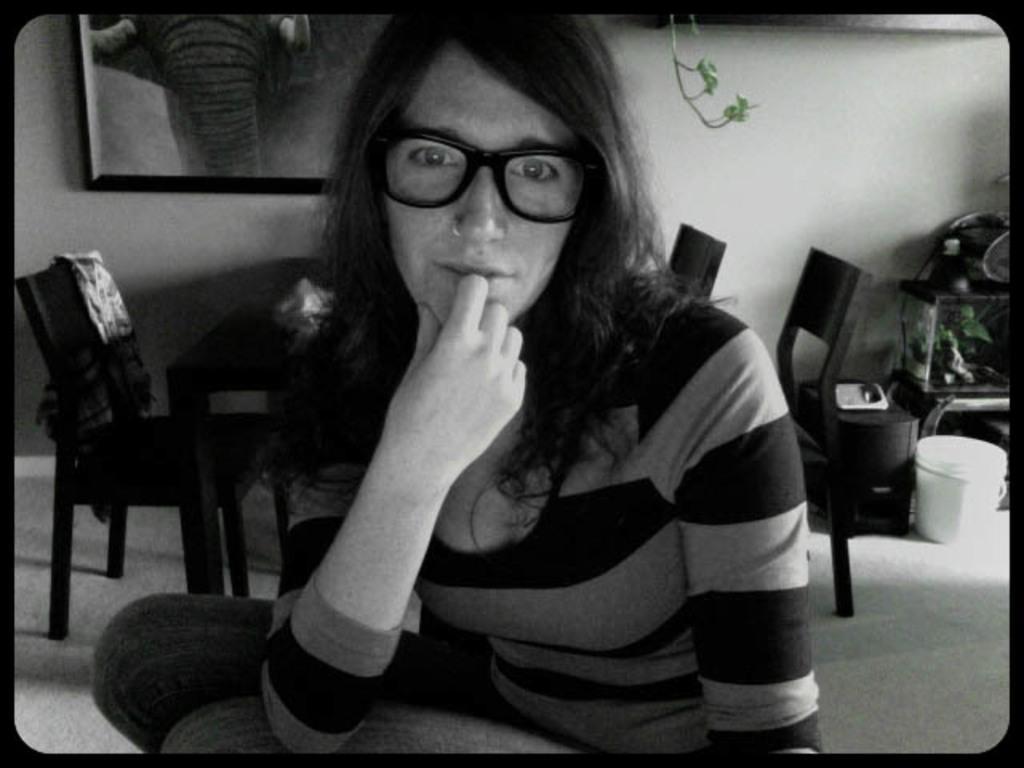Please provide a concise description of this image. In this picture, we can see a person, we can see the ground, and some objects on the ground, like chairs, tables, and some objects on the right side of the picture, we can see the wall with some objects attached to it. 